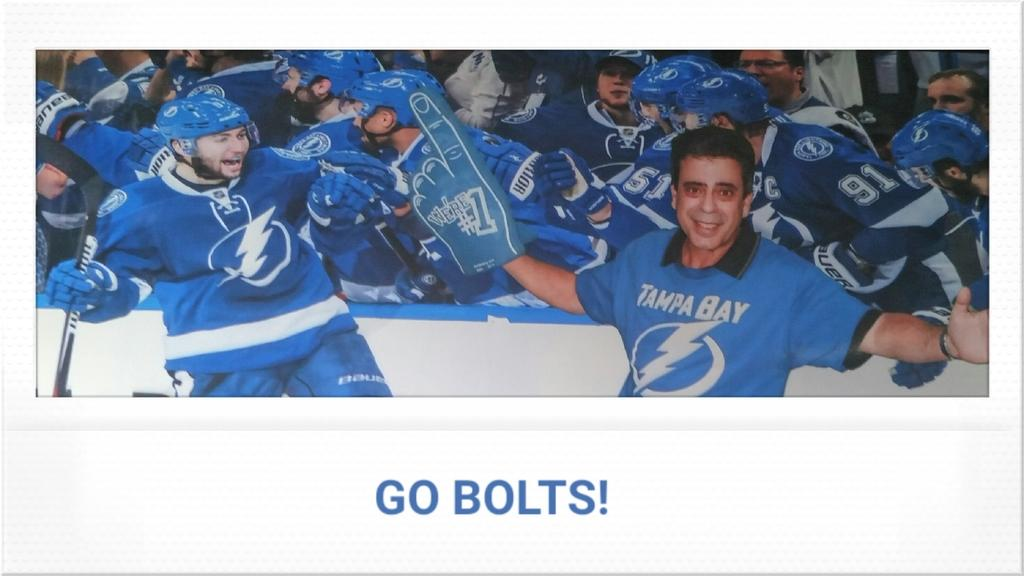<image>
Summarize the visual content of the image. A sign for the Tampa Bay team says "Go Bolts!". 